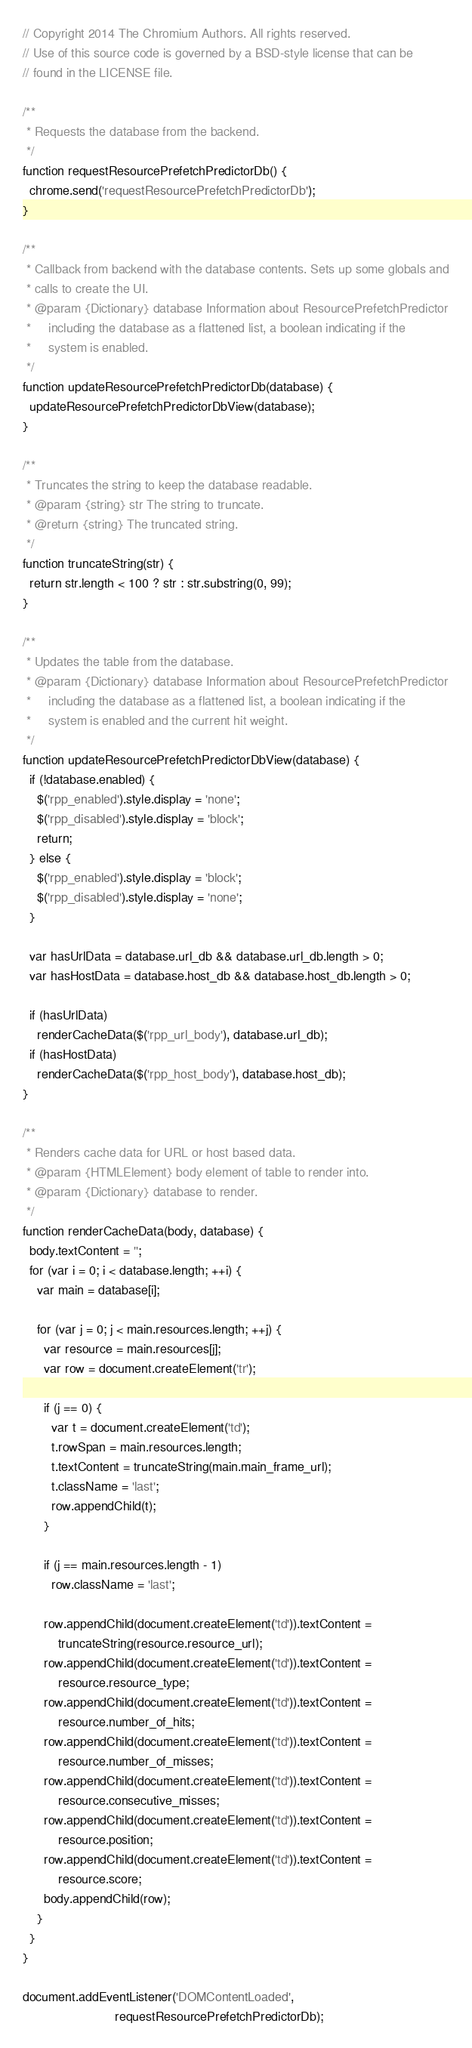<code> <loc_0><loc_0><loc_500><loc_500><_JavaScript_>// Copyright 2014 The Chromium Authors. All rights reserved.
// Use of this source code is governed by a BSD-style license that can be
// found in the LICENSE file.

/**
 * Requests the database from the backend.
 */
function requestResourcePrefetchPredictorDb() {
  chrome.send('requestResourcePrefetchPredictorDb');
}

/**
 * Callback from backend with the database contents. Sets up some globals and
 * calls to create the UI.
 * @param {Dictionary} database Information about ResourcePrefetchPredictor
 *     including the database as a flattened list, a boolean indicating if the
 *     system is enabled.
 */
function updateResourcePrefetchPredictorDb(database) {
  updateResourcePrefetchPredictorDbView(database);
}

/**
 * Truncates the string to keep the database readable.
 * @param {string} str The string to truncate.
 * @return {string} The truncated string.
 */
function truncateString(str) {
  return str.length < 100 ? str : str.substring(0, 99);
}

/**
 * Updates the table from the database.
 * @param {Dictionary} database Information about ResourcePrefetchPredictor
 *     including the database as a flattened list, a boolean indicating if the
 *     system is enabled and the current hit weight.
 */
function updateResourcePrefetchPredictorDbView(database) {
  if (!database.enabled) {
    $('rpp_enabled').style.display = 'none';
    $('rpp_disabled').style.display = 'block';
    return;
  } else {
    $('rpp_enabled').style.display = 'block';
    $('rpp_disabled').style.display = 'none';
  }

  var hasUrlData = database.url_db && database.url_db.length > 0;
  var hasHostData = database.host_db && database.host_db.length > 0;

  if (hasUrlData)
    renderCacheData($('rpp_url_body'), database.url_db);
  if (hasHostData)
    renderCacheData($('rpp_host_body'), database.host_db);
}

/**
 * Renders cache data for URL or host based data.
 * @param {HTMLElement} body element of table to render into.
 * @param {Dictionary} database to render.
 */
function renderCacheData(body, database) {
  body.textContent = '';
  for (var i = 0; i < database.length; ++i) {
    var main = database[i];

    for (var j = 0; j < main.resources.length; ++j) {
      var resource = main.resources[j];
      var row = document.createElement('tr');

      if (j == 0) {
        var t = document.createElement('td');
        t.rowSpan = main.resources.length;
        t.textContent = truncateString(main.main_frame_url);
        t.className = 'last';
        row.appendChild(t);
      }

      if (j == main.resources.length - 1)
        row.className = 'last';

      row.appendChild(document.createElement('td')).textContent =
          truncateString(resource.resource_url);
      row.appendChild(document.createElement('td')).textContent =
          resource.resource_type;
      row.appendChild(document.createElement('td')).textContent =
          resource.number_of_hits;
      row.appendChild(document.createElement('td')).textContent =
          resource.number_of_misses;
      row.appendChild(document.createElement('td')).textContent =
          resource.consecutive_misses;
      row.appendChild(document.createElement('td')).textContent =
          resource.position;
      row.appendChild(document.createElement('td')).textContent =
          resource.score;
      body.appendChild(row);
    }
  }
}

document.addEventListener('DOMContentLoaded',
                          requestResourcePrefetchPredictorDb);
</code> 